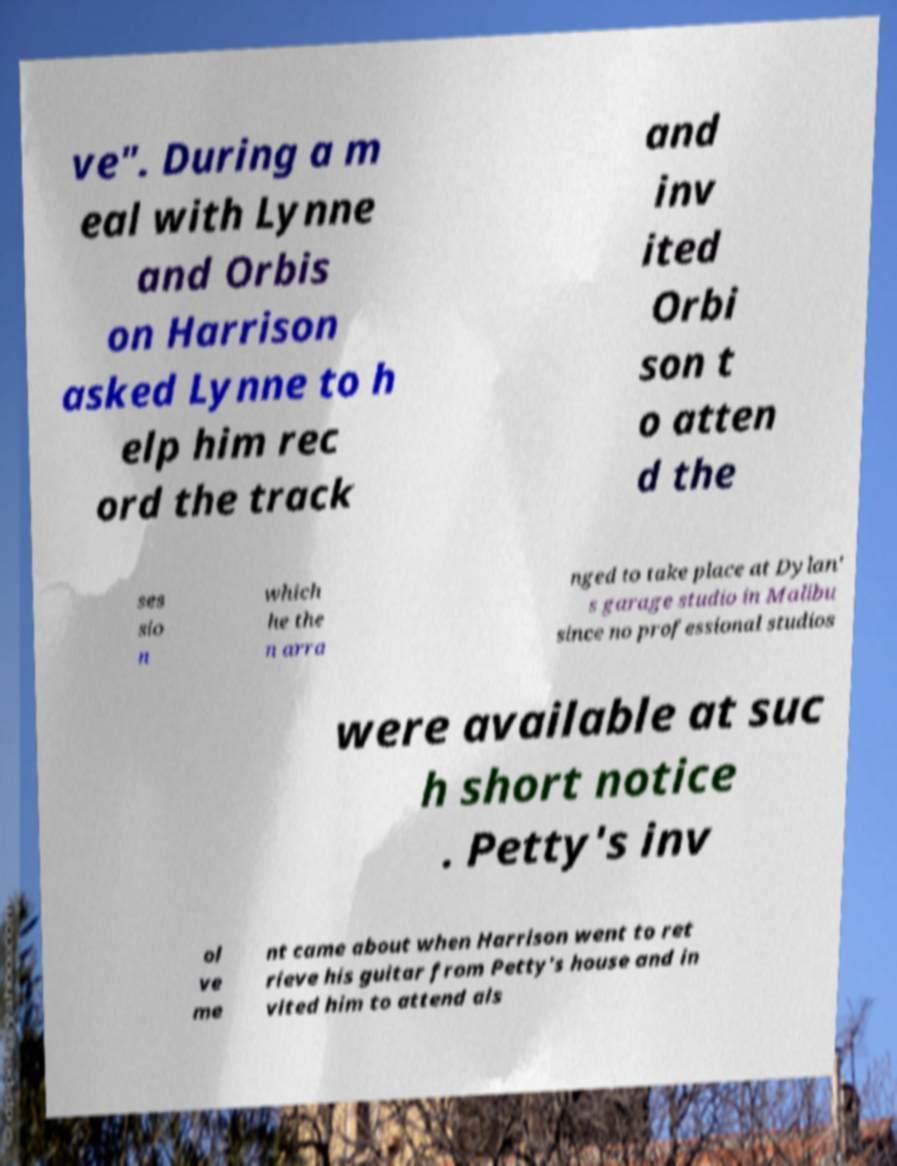Please identify and transcribe the text found in this image. ve". During a m eal with Lynne and Orbis on Harrison asked Lynne to h elp him rec ord the track and inv ited Orbi son t o atten d the ses sio n which he the n arra nged to take place at Dylan' s garage studio in Malibu since no professional studios were available at suc h short notice . Petty's inv ol ve me nt came about when Harrison went to ret rieve his guitar from Petty's house and in vited him to attend als 